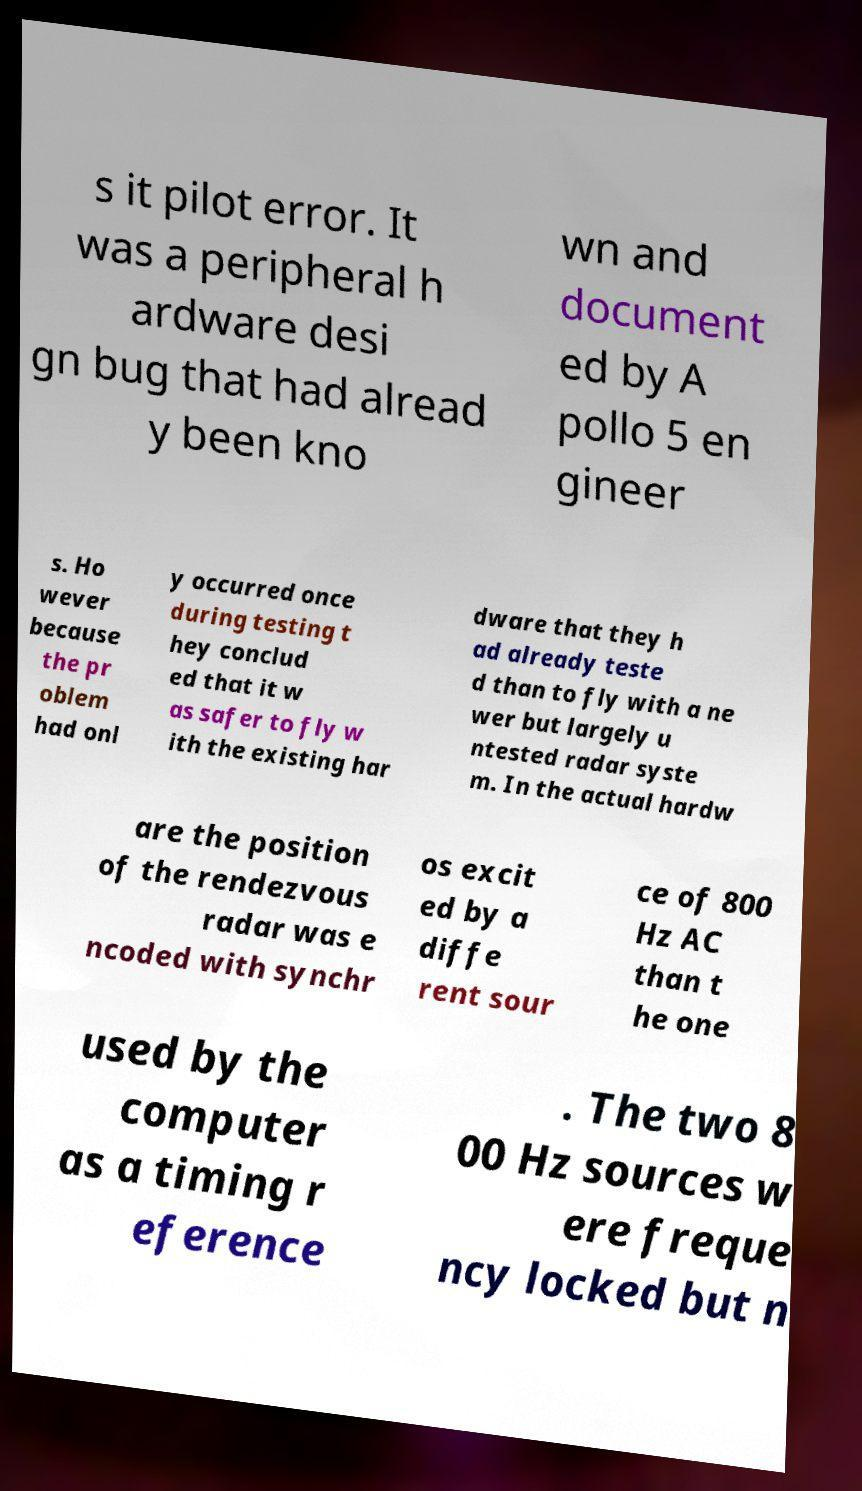Can you accurately transcribe the text from the provided image for me? s it pilot error. It was a peripheral h ardware desi gn bug that had alread y been kno wn and document ed by A pollo 5 en gineer s. Ho wever because the pr oblem had onl y occurred once during testing t hey conclud ed that it w as safer to fly w ith the existing har dware that they h ad already teste d than to fly with a ne wer but largely u ntested radar syste m. In the actual hardw are the position of the rendezvous radar was e ncoded with synchr os excit ed by a diffe rent sour ce of 800 Hz AC than t he one used by the computer as a timing r eference . The two 8 00 Hz sources w ere freque ncy locked but n 